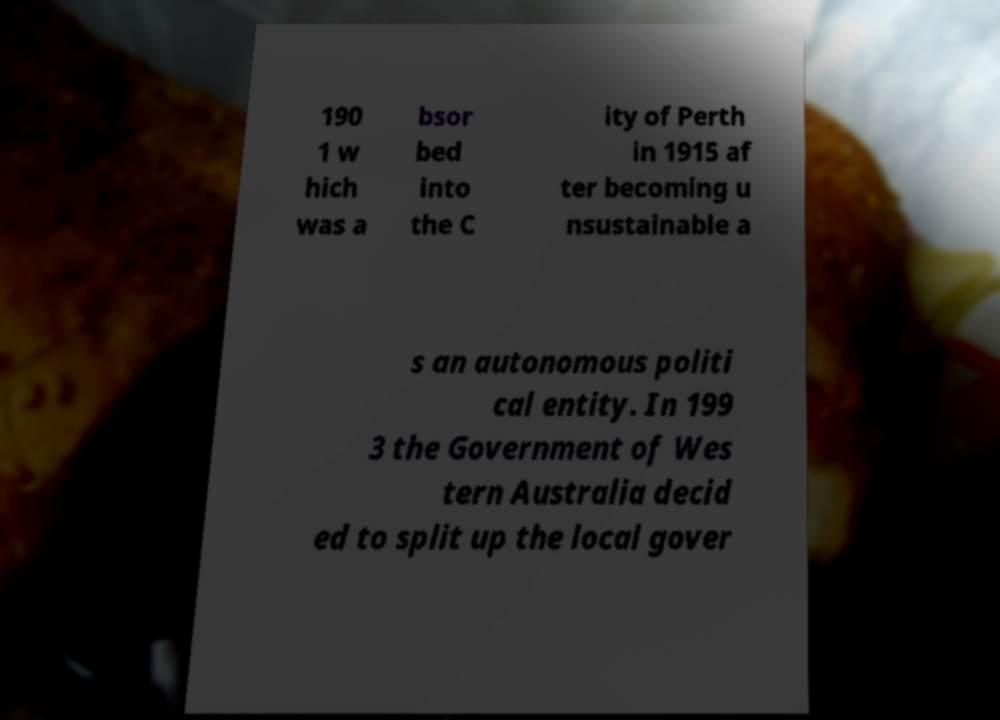Could you assist in decoding the text presented in this image and type it out clearly? 190 1 w hich was a bsor bed into the C ity of Perth in 1915 af ter becoming u nsustainable a s an autonomous politi cal entity. In 199 3 the Government of Wes tern Australia decid ed to split up the local gover 